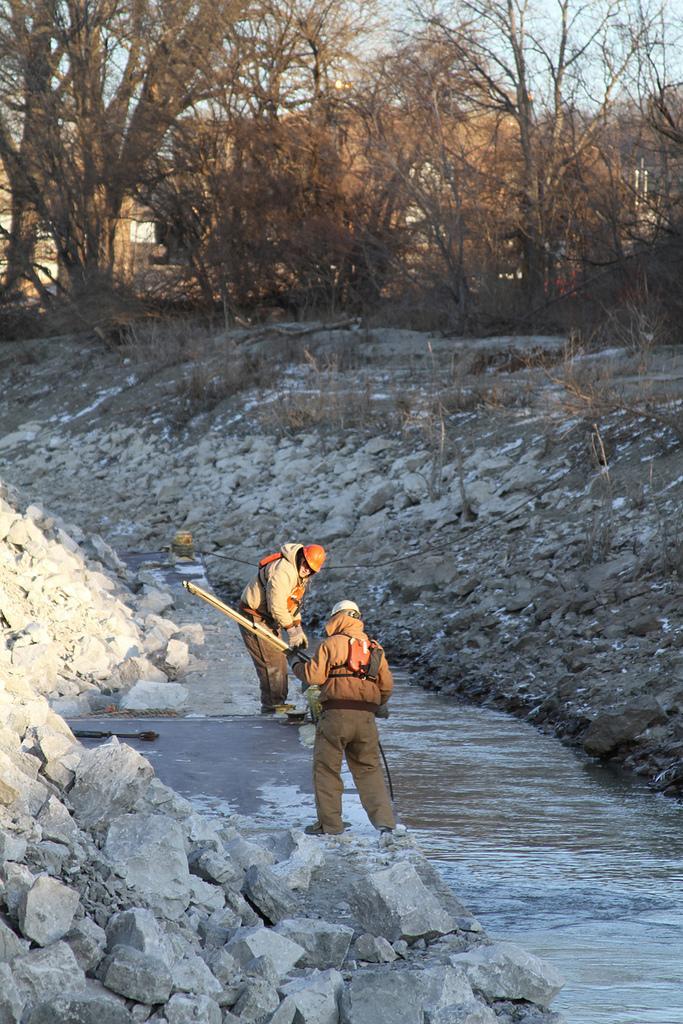Can you describe this image briefly? In this image I can see two people are standing and holding something. I can see few stones, water, dry trees. The sky is in blue color. 